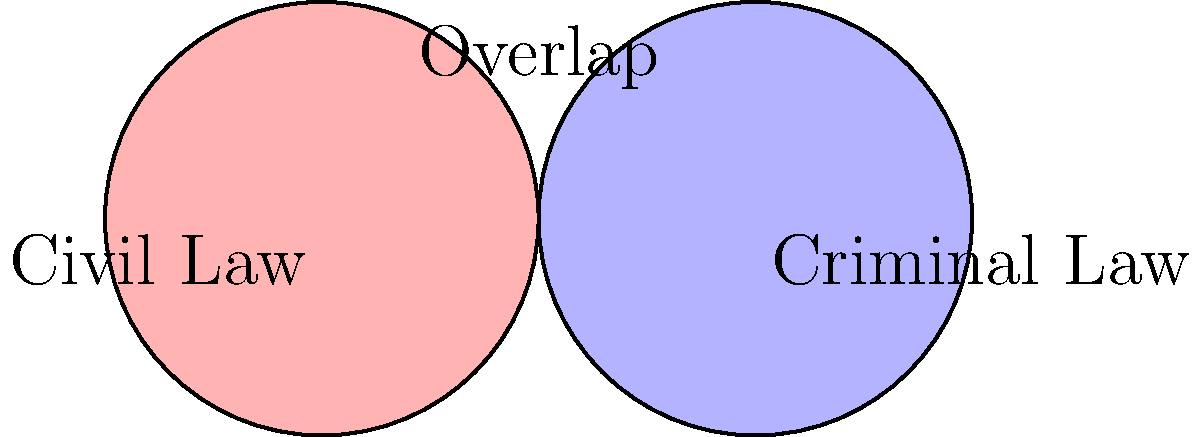Based on the Venn diagram illustrating the overlap between civil and criminal law, which area of law is most likely to involve both civil and criminal proceedings in cases related to technological advancements? To answer this question, we need to analyze the Venn diagram and consider the areas of law that fall within the overlap between civil and criminal law, particularly those that may be affected by technological advancements. Let's break it down step-by-step:

1. The Venn diagram shows two circles: one for Civil Law and one for Criminal Law.
2. The overlapping area represents legal matters that can involve both civil and criminal proceedings.
3. In the overlapping area, we can see two specific areas of law: White-collar Crime and Cybercrime.
4. White-collar crime typically involves financial fraud or other non-violent crimes committed in a business or professional setting.
5. Cybercrime, on the other hand, specifically relates to criminal activities carried out using computers and the internet.
6. When considering technological advancements, cybercrime is more directly linked to new and emerging technologies.
7. Cybercrime cases often involve both criminal prosecution (e.g., for hacking or data theft) and civil litigation (e.g., for damages resulting from the crime).
8. Therefore, cybercrime is the area of law most likely to involve both civil and criminal proceedings in cases related to technological advancements.
Answer: Cybercrime 